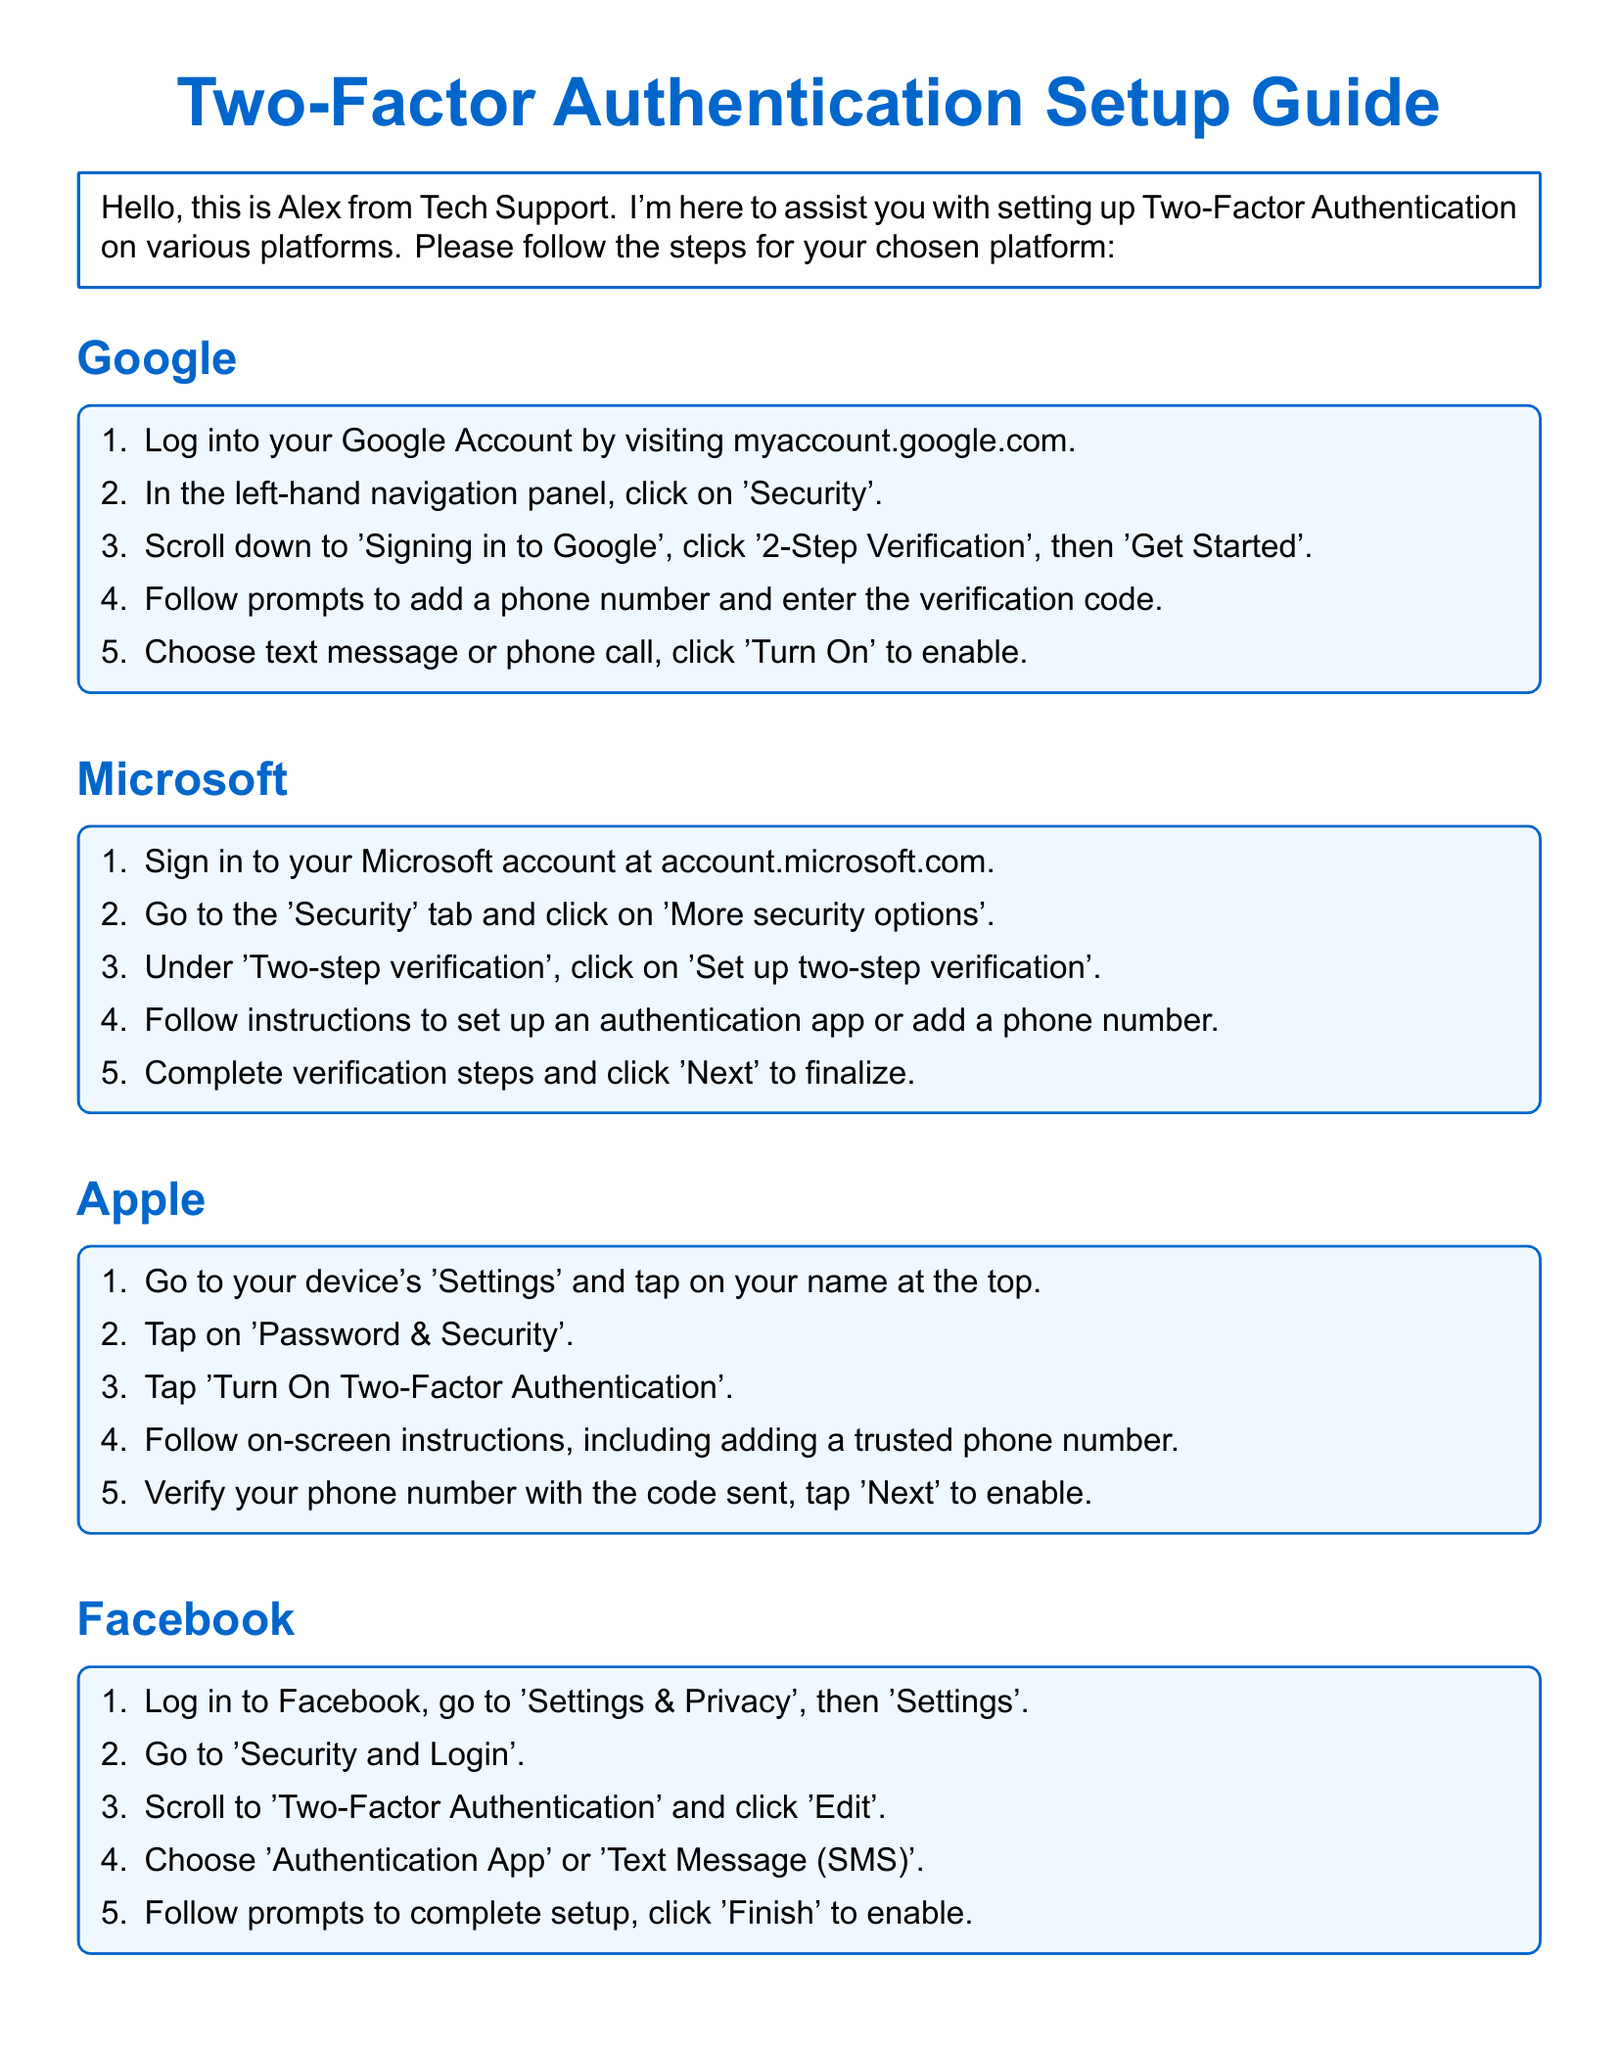what is the main title of the document? The main title of the document is found at the top and identifies the purpose of the content.
Answer: Two-Factor Authentication Setup Guide who is the author of the support guide? The author's name is provided in the introduction of the document, indicating who is assisting with the setup.
Answer: Alex how many platforms are covered in the document? The document includes a section for each platform, and by counting, we find out the total number covered.
Answer: Four which platform instructions start with "Log into your Google Account"? This phrase is specifically mentioned in the instructions for one platform, identifying it clearly.
Answer: Google what should you use alongside Two-Factor Authentication according to the general tips? The general tips suggest a specific security measure to use in conjunction with Two-Factor Authentication.
Answer: Strong and unique password what is the last step of the Facebook setup process? The final step is described in the Facebook section, indicating completion of the setup.
Answer: Click 'Finish' to enable how do you verify your phone number for Apple? The verification process for Apple involves following the steps outlined, specifically one step includes receiving a code.
Answer: Verify your phone number with the code sent what color is the background of the steps boxes? The documents specify a particular color used for the background of the steps boxes throughout the guide.
Answer: Light blue which authentication apps are suggested in the general tips? The document mentions specific apps that are recommended for enhanced security.
Answer: Google Authenticator or Authy 